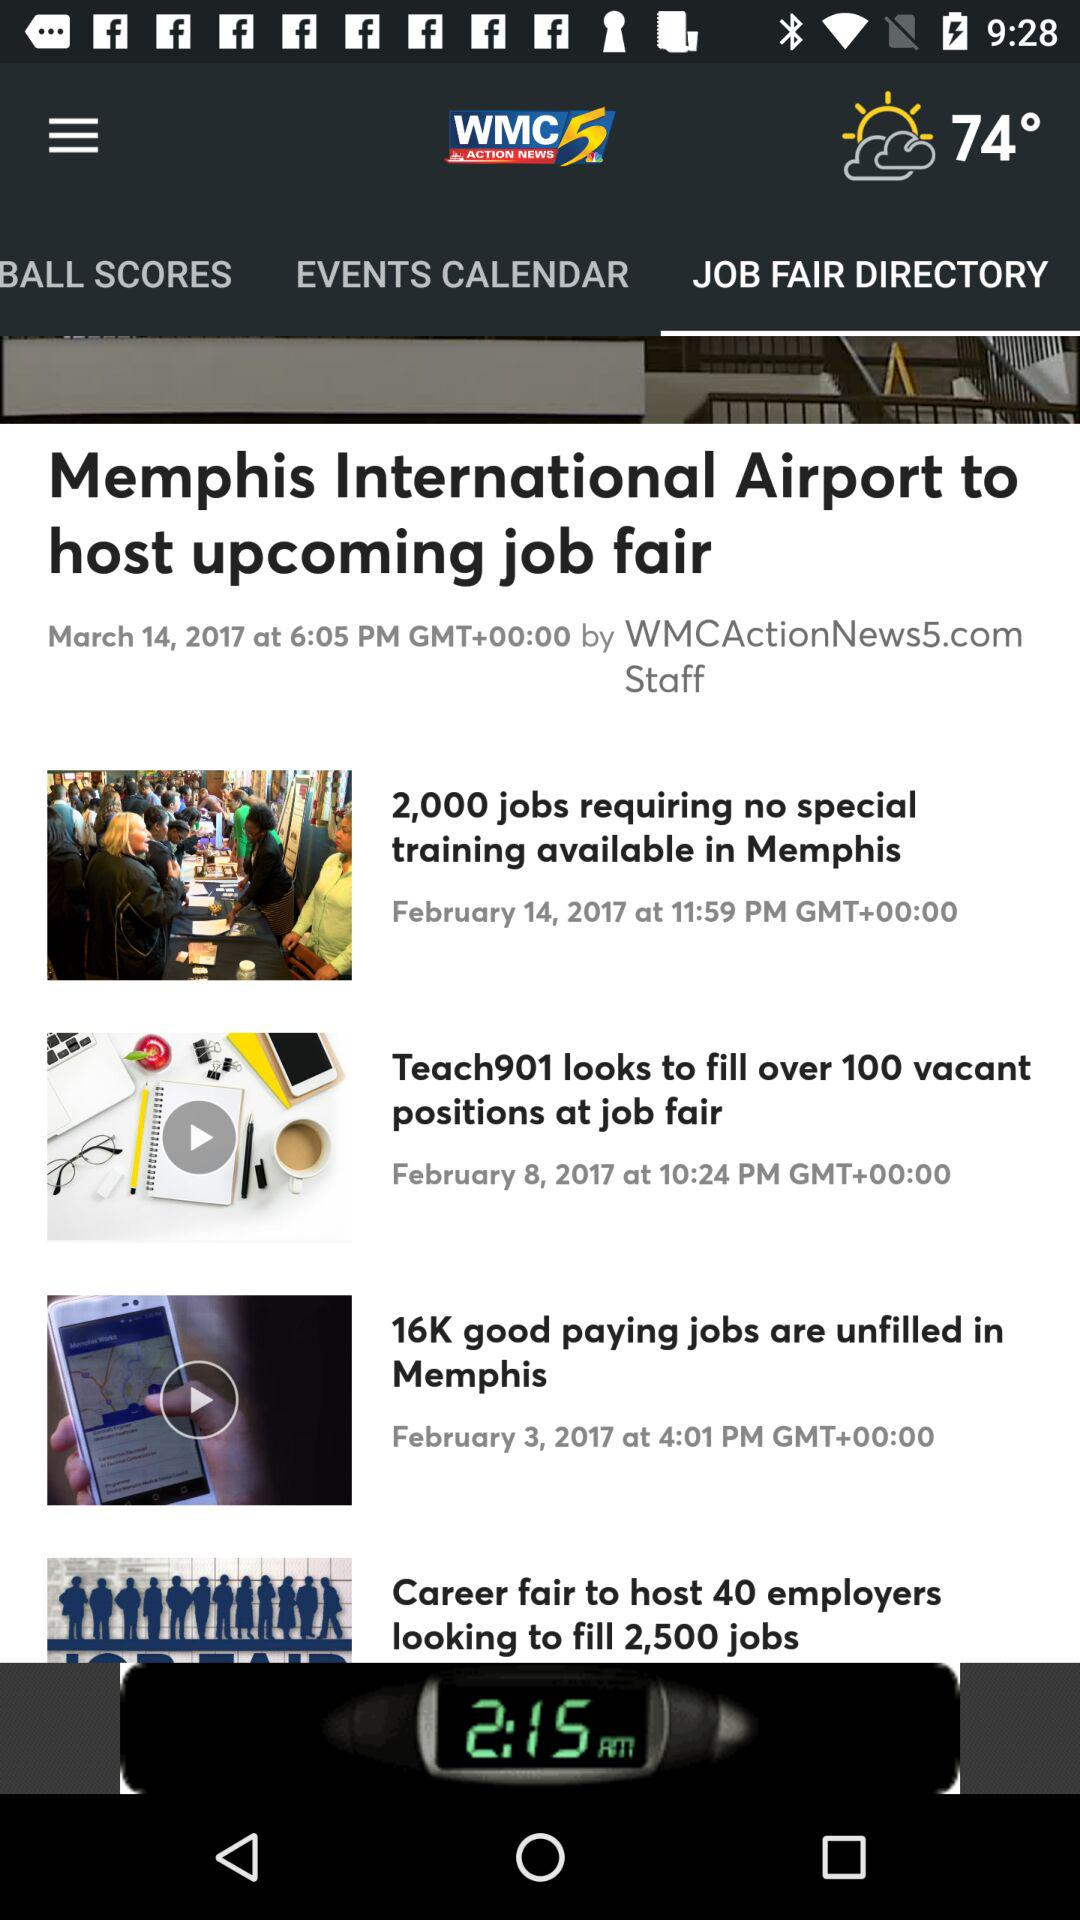What is the temperature shown on the screen? The temperature is 74°. 